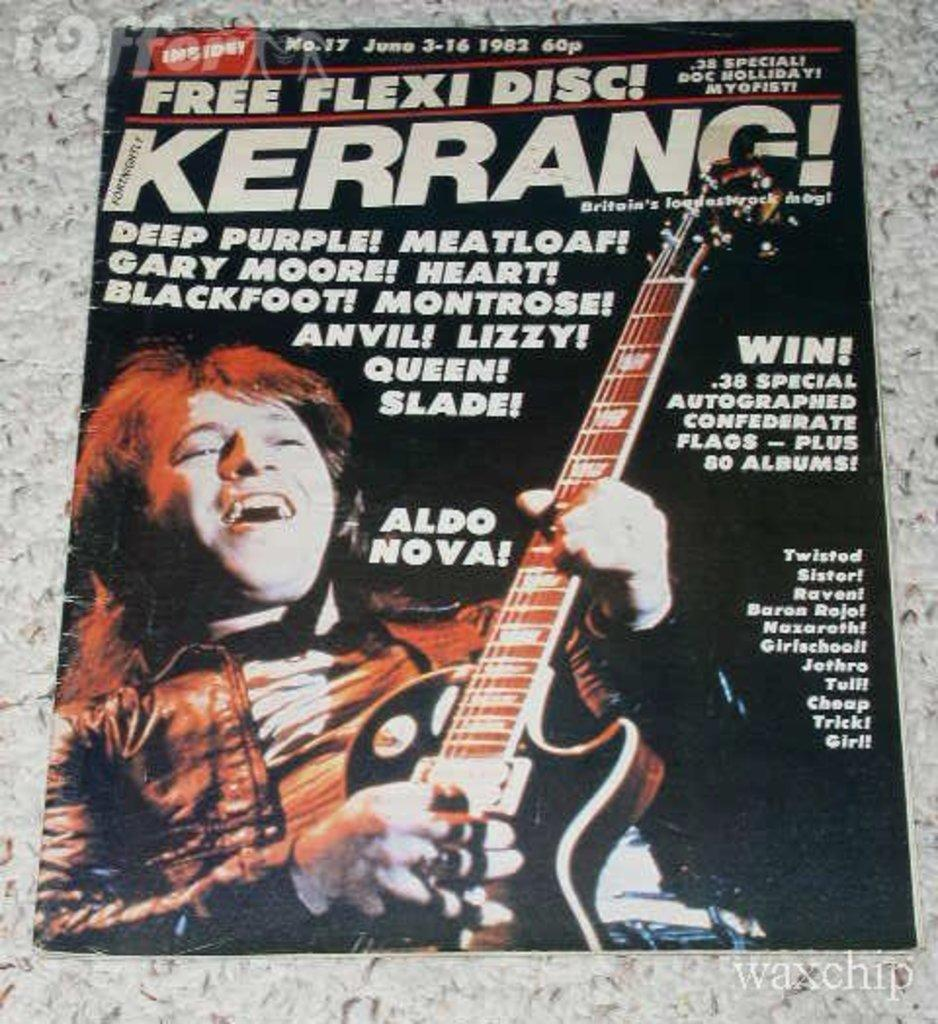What object can be seen in the image that people often read? There is a magazine in the image that people often read. What is the person in the image doing? The person is holding a guitar in the image. Can you describe any additional details about the guitar? Yes, there is writing on the guitar. What color or type of surface is the magazine resting on? The magazine is on a grey surface. What type of magic is being performed with the tongue in the image? There is no magic or tongue present in the image. Can you describe the color or type of paint used on the guitar? There is no mention of paint on the guitar in the provided facts, so we cannot describe its color or type. 